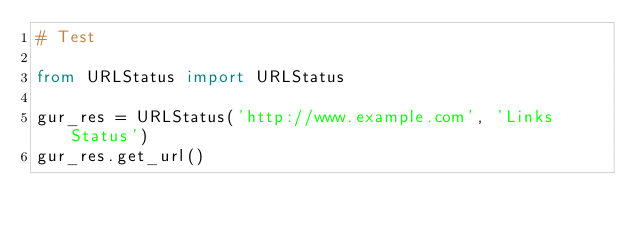<code> <loc_0><loc_0><loc_500><loc_500><_Python_># Test

from URLStatus import URLStatus

gur_res = URLStatus('http://www.example.com', 'Links Status')
gur_res.get_url()
</code> 